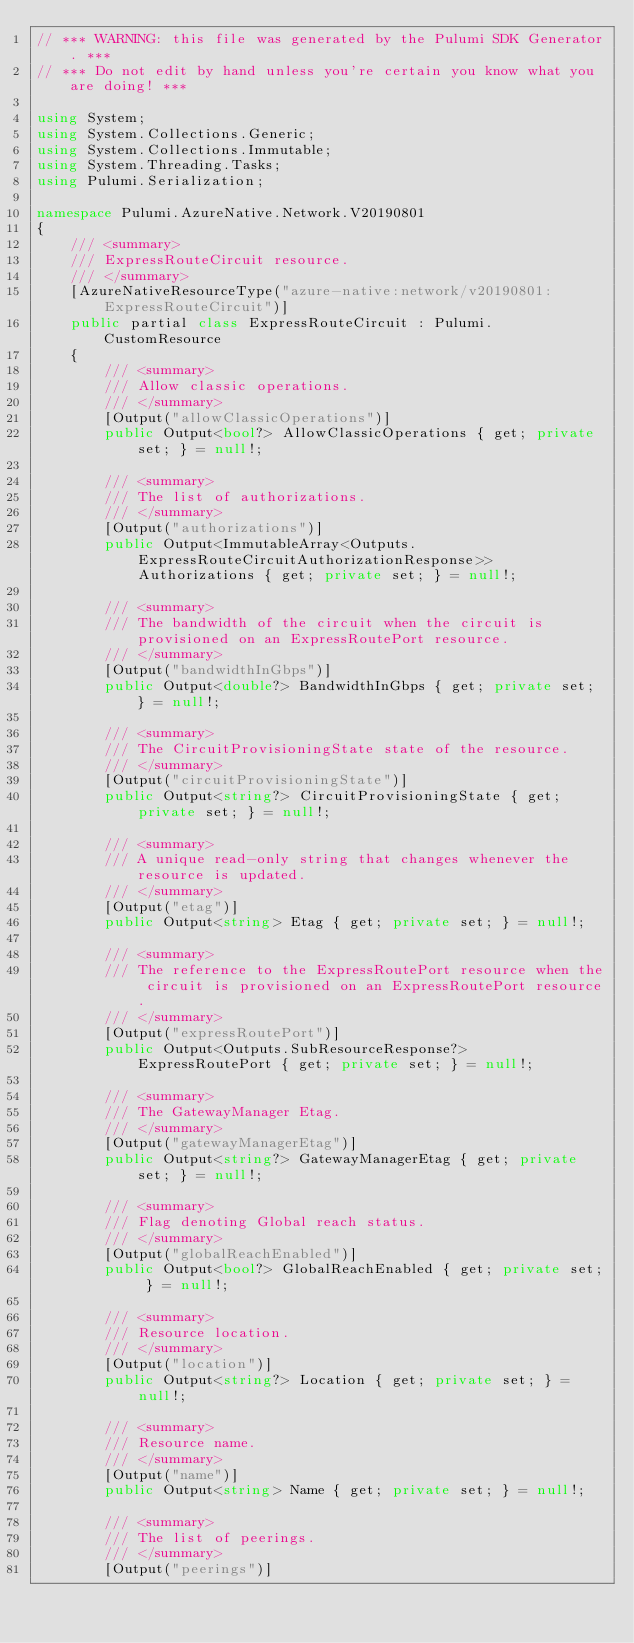<code> <loc_0><loc_0><loc_500><loc_500><_C#_>// *** WARNING: this file was generated by the Pulumi SDK Generator. ***
// *** Do not edit by hand unless you're certain you know what you are doing! ***

using System;
using System.Collections.Generic;
using System.Collections.Immutable;
using System.Threading.Tasks;
using Pulumi.Serialization;

namespace Pulumi.AzureNative.Network.V20190801
{
    /// <summary>
    /// ExpressRouteCircuit resource.
    /// </summary>
    [AzureNativeResourceType("azure-native:network/v20190801:ExpressRouteCircuit")]
    public partial class ExpressRouteCircuit : Pulumi.CustomResource
    {
        /// <summary>
        /// Allow classic operations.
        /// </summary>
        [Output("allowClassicOperations")]
        public Output<bool?> AllowClassicOperations { get; private set; } = null!;

        /// <summary>
        /// The list of authorizations.
        /// </summary>
        [Output("authorizations")]
        public Output<ImmutableArray<Outputs.ExpressRouteCircuitAuthorizationResponse>> Authorizations { get; private set; } = null!;

        /// <summary>
        /// The bandwidth of the circuit when the circuit is provisioned on an ExpressRoutePort resource.
        /// </summary>
        [Output("bandwidthInGbps")]
        public Output<double?> BandwidthInGbps { get; private set; } = null!;

        /// <summary>
        /// The CircuitProvisioningState state of the resource.
        /// </summary>
        [Output("circuitProvisioningState")]
        public Output<string?> CircuitProvisioningState { get; private set; } = null!;

        /// <summary>
        /// A unique read-only string that changes whenever the resource is updated.
        /// </summary>
        [Output("etag")]
        public Output<string> Etag { get; private set; } = null!;

        /// <summary>
        /// The reference to the ExpressRoutePort resource when the circuit is provisioned on an ExpressRoutePort resource.
        /// </summary>
        [Output("expressRoutePort")]
        public Output<Outputs.SubResourceResponse?> ExpressRoutePort { get; private set; } = null!;

        /// <summary>
        /// The GatewayManager Etag.
        /// </summary>
        [Output("gatewayManagerEtag")]
        public Output<string?> GatewayManagerEtag { get; private set; } = null!;

        /// <summary>
        /// Flag denoting Global reach status.
        /// </summary>
        [Output("globalReachEnabled")]
        public Output<bool?> GlobalReachEnabled { get; private set; } = null!;

        /// <summary>
        /// Resource location.
        /// </summary>
        [Output("location")]
        public Output<string?> Location { get; private set; } = null!;

        /// <summary>
        /// Resource name.
        /// </summary>
        [Output("name")]
        public Output<string> Name { get; private set; } = null!;

        /// <summary>
        /// The list of peerings.
        /// </summary>
        [Output("peerings")]</code> 